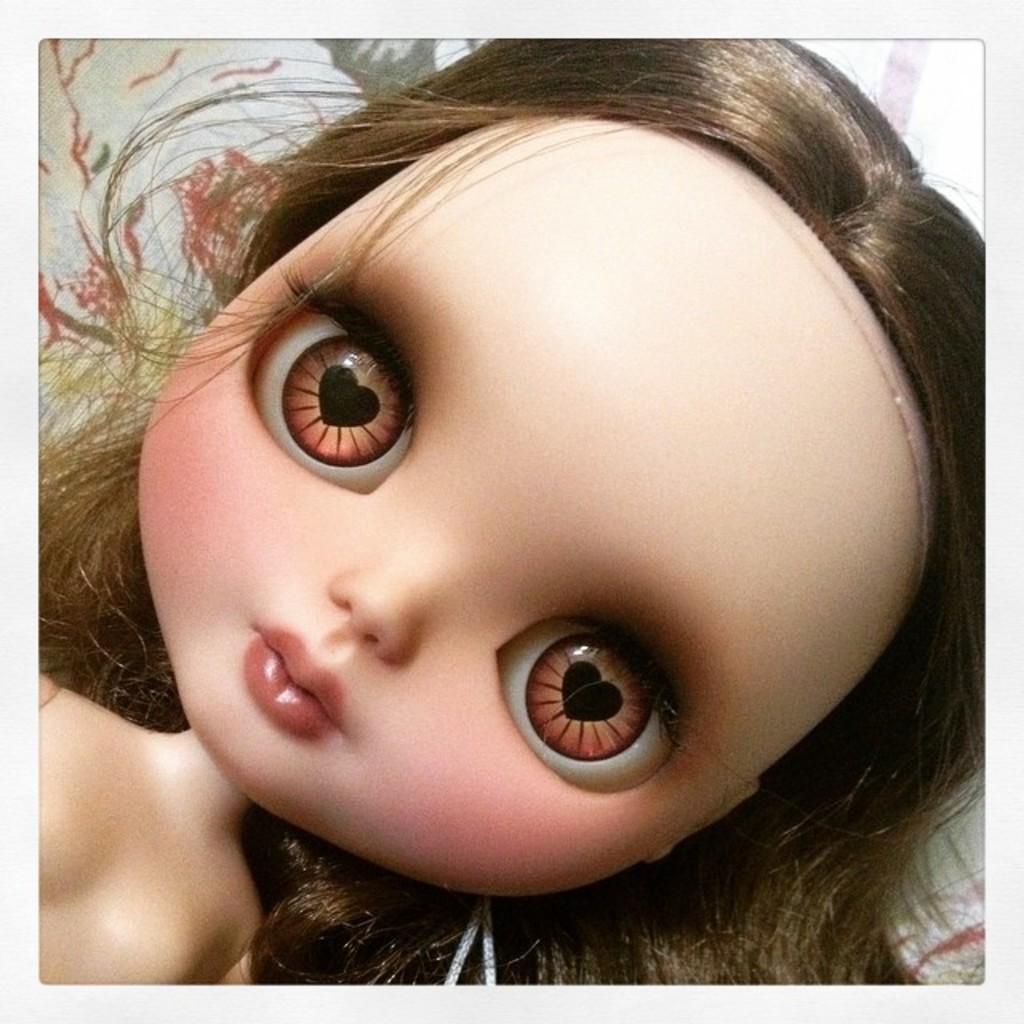How would you summarize this image in a sentence or two? In the middle of the image there is a toy lying on the bed. It is with big eyes and a short nose. 